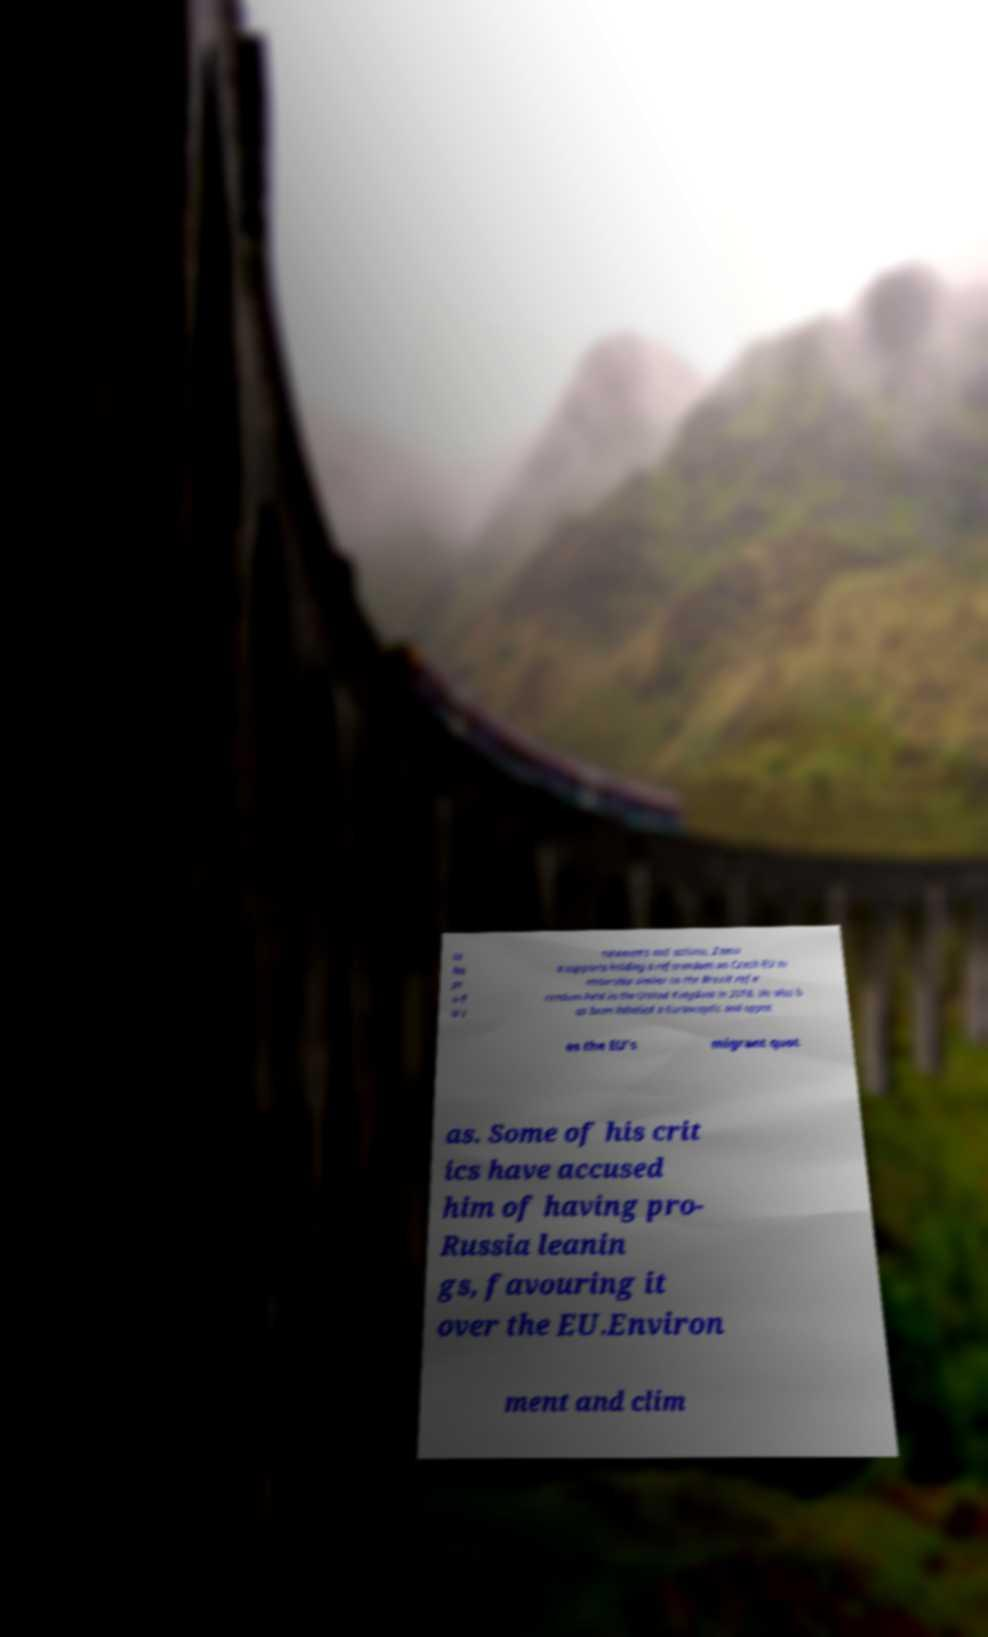There's text embedded in this image that I need extracted. Can you transcribe it verbatim? te his pr o-E U s tatements and actions, Zema n supports holding a referendum on Czech EU m embership similar to the Brexit refe rendum held in the United Kingdom in 2016. He also h as been labelled a Eurosceptic and oppos es the EU's migrant quot as. Some of his crit ics have accused him of having pro- Russia leanin gs, favouring it over the EU.Environ ment and clim 